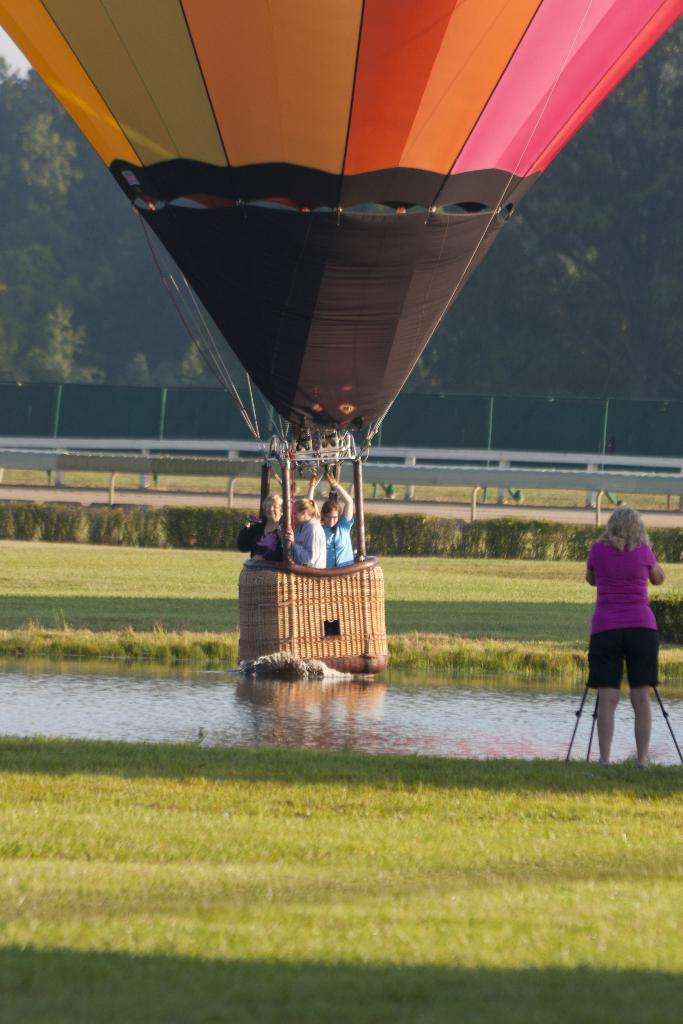How would you summarize this image in a sentence or two? In this image we can see a few people enjoying the hot air balloon ride. Here we can see a woman on the left side and looks like she is capturing an image with a camera. Here we can see the water and grass. This is looking like metal fence. In the background, we can see the trees. 